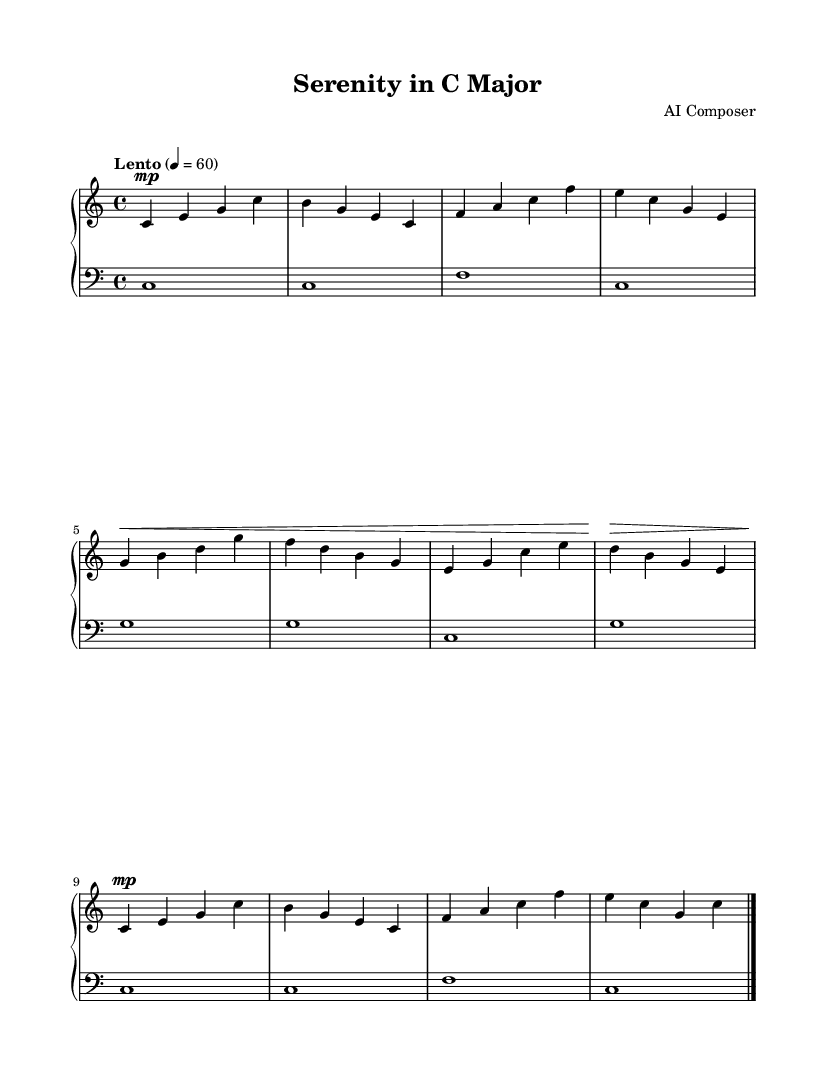What is the key signature of this music? The key signature is indicated by the absence of sharps or flats on the stave, which corresponds to C major.
Answer: C major What is the time signature of this piece? The time signature is represented by the numbers at the beginning of the music, which is 4 over 4, indicating four beats in a measure.
Answer: 4/4 What is the tempo marking for this piece? The tempo marking is shown at the beginning of the music, stating "Lento" with a metronome marking of 4 = 60, suggesting a slow pace.
Answer: Lento How many measures are in the A section? The A section consists of the notes indicated before moving to the B section; counting the measures reveals there are four measures.
Answer: 4 Which section features a crescendo? The music shows a crescendo sign before the B section, indicating that this is where the dynamic intensity builds.
Answer: B section What is the dynamic marking for the return of the A section? The A' section indicates a dynamic marking of "mp" (mezzo piano), which means moderately soft.
Answer: mp What instrument is the score written for? The score specifies the MIDI instrument at the beginning, which is labeled as “acoustic grand,” indicating it is for piano.
Answer: Acoustic grand 